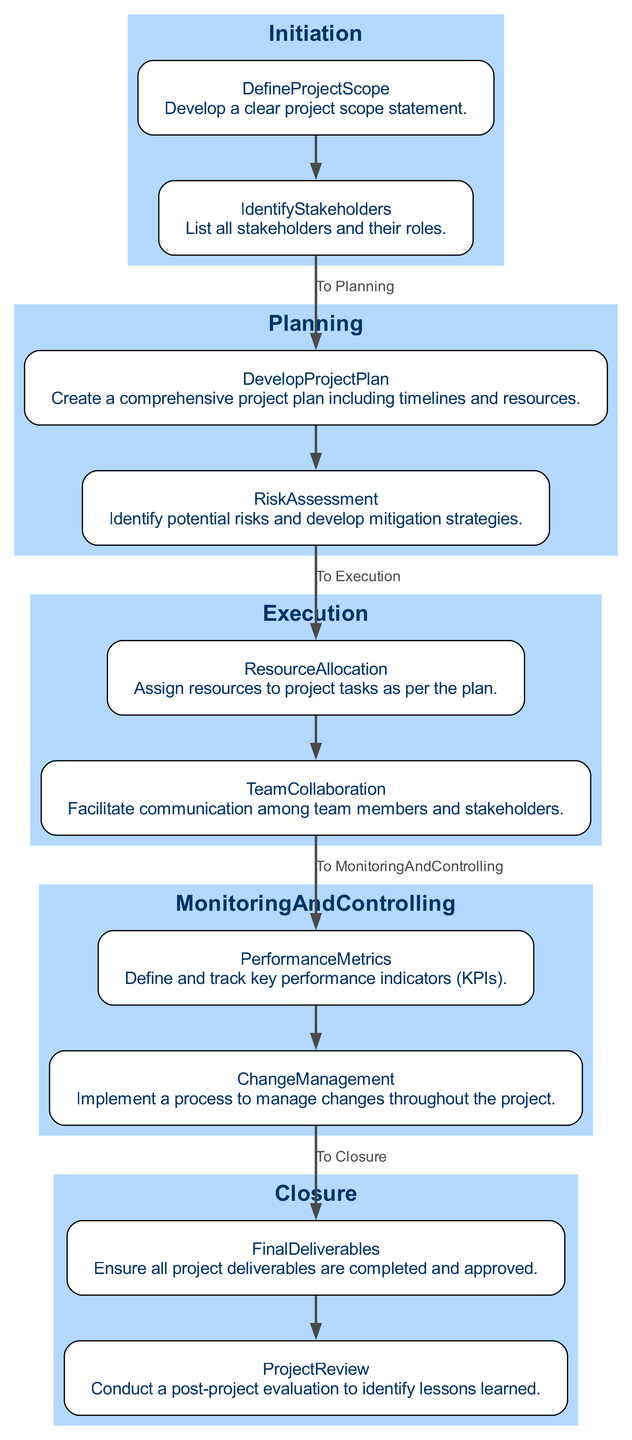What are the main phases of the project lifecycle? The main phases are Initiation, Planning, Execution, Monitoring and Controlling, and Closure. These phases are represented as distinct clusters in the diagram.
Answer: Initiation, Planning, Execution, Monitoring and Controlling, Closure How many tasks are in the Planning phase? In the Planning phase, there are two tasks: Develop Project Plan and Risk Assessment. The diagram shows these two tasks listed under the Planning phase.
Answer: 2 What does the Execution phase focus on? The Execution phase focuses on resource allocation and team collaboration. These are the two tasks that are displayed in this phase within the diagram.
Answer: Resource Allocation and Team Collaboration What connects the final task of the Initiation phase to the first task of the Planning phase? The connection is represented by an edge labeled "To Planning," which indicates the progression from the last task in Initiation to the first task in Planning.
Answer: To Planning What is the last task in the Closure phase? The last task in the Closure phase is the Project Review, which is shown as part of this phase in the diagram.
Answer: Project Review How many edges are in the entire diagram? The diagram connects all tasks within phases as well as between phases, totaling seven edges that illustrate these connections. By counting each arrow connecting tasks, we find that there are seven in total.
Answer: 7 What is the purpose of the Monitoring and Controlling phase? The Monitoring and Controlling phase serves to define and track key performance indicators as well as manage changes throughout the project, as indicated by the tasks listed under this phase in the diagram.
Answer: Define and track KPIs, Manage changes What task follows Risk Assessment in the Planning phase? Following Risk Assessment in the Planning phase is the Develop Project Plan task. The diagram illustrates this sequential relationship.
Answer: Develop Project Plan Which task is connected to Change Management? Change Management connects to Performance Metrics in the Monitoring and Controlling phase. The diagram shows these tasks as part of the Monitoring and Controlling phase and linked through their edge connection.
Answer: Performance Metrics 